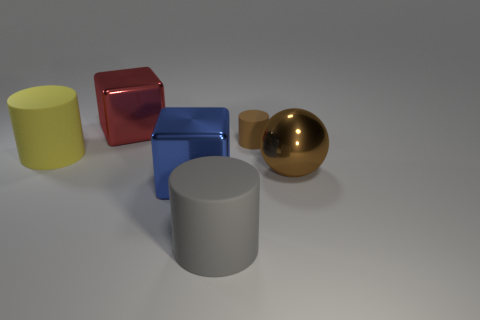Is there any other thing that has the same shape as the big brown thing?
Provide a short and direct response. No. How many other things are there of the same size as the brown rubber object?
Offer a very short reply. 0. The cylinder that is both right of the big yellow object and on the left side of the small brown thing is made of what material?
Ensure brevity in your answer.  Rubber. There is a metal sphere; is its color the same as the tiny matte cylinder left of the brown metal object?
Your response must be concise. Yes. There is a brown matte object that is the same shape as the large yellow matte object; what size is it?
Your answer should be very brief. Small. What shape is the metallic thing that is both behind the blue metal cube and on the right side of the big red block?
Provide a short and direct response. Sphere. Do the gray object and the matte thing on the left side of the large gray matte cylinder have the same size?
Make the answer very short. Yes. There is another metallic object that is the same shape as the blue metal object; what color is it?
Keep it short and to the point. Red. Is the size of the object that is behind the small rubber object the same as the rubber cylinder behind the yellow cylinder?
Keep it short and to the point. No. Do the big gray object and the large yellow object have the same shape?
Offer a very short reply. Yes. 